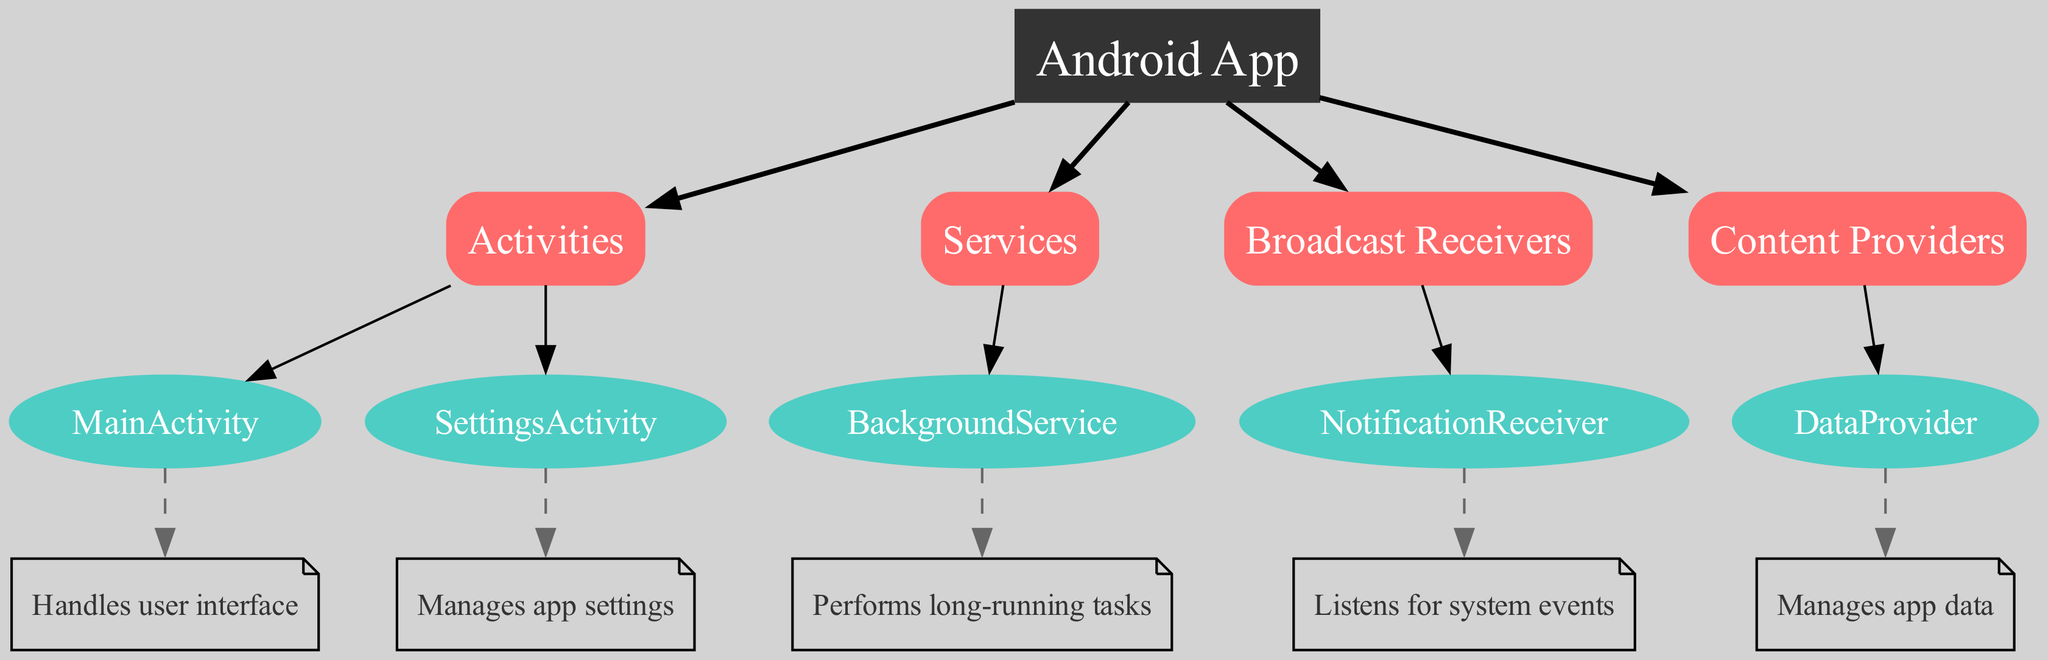What are the four main components of an Android app? The diagram lists four main components under the "App" node: Activities, Services, Broadcast Receivers, and Content Providers.
Answer: Activities, Services, Broadcast Receivers, Content Providers How many activities are shown in the diagram? There are two activities listed: MainActivity and SettingsActivity, both under the "Activities" node.
Answer: 2 What does the MainActivity component handle? According to the description provided in the diagram, the MainActivity handles the user interface of the app.
Answer: User interface Which component is responsible for long-running tasks? The BackgroundService under the "Services" category performs long-running tasks as described in the diagram.
Answer: BackgroundService What type of node is "NotificationReceiver"? The NotificationReceiver is categorized as a leaf node since it does not have any children, meaning it does not further branch out.
Answer: Leaf node Which component listens for system events? The diagram indicates that the NotificationReceiver listens for system events as its primary function.
Answer: NotificationReceiver How many content providers are mentioned in the diagram? The diagram shows only one content provider, named DataProvider.
Answer: 1 What is the primary role of the DataProvider? The diagram describes the role of DataProvider as managing app data.
Answer: Manages app data Which component would you find under the category of Broadcast Receivers? The NotificationReceiver is the only component listed under the Broadcast Receivers category in the diagram.
Answer: NotificationReceiver 